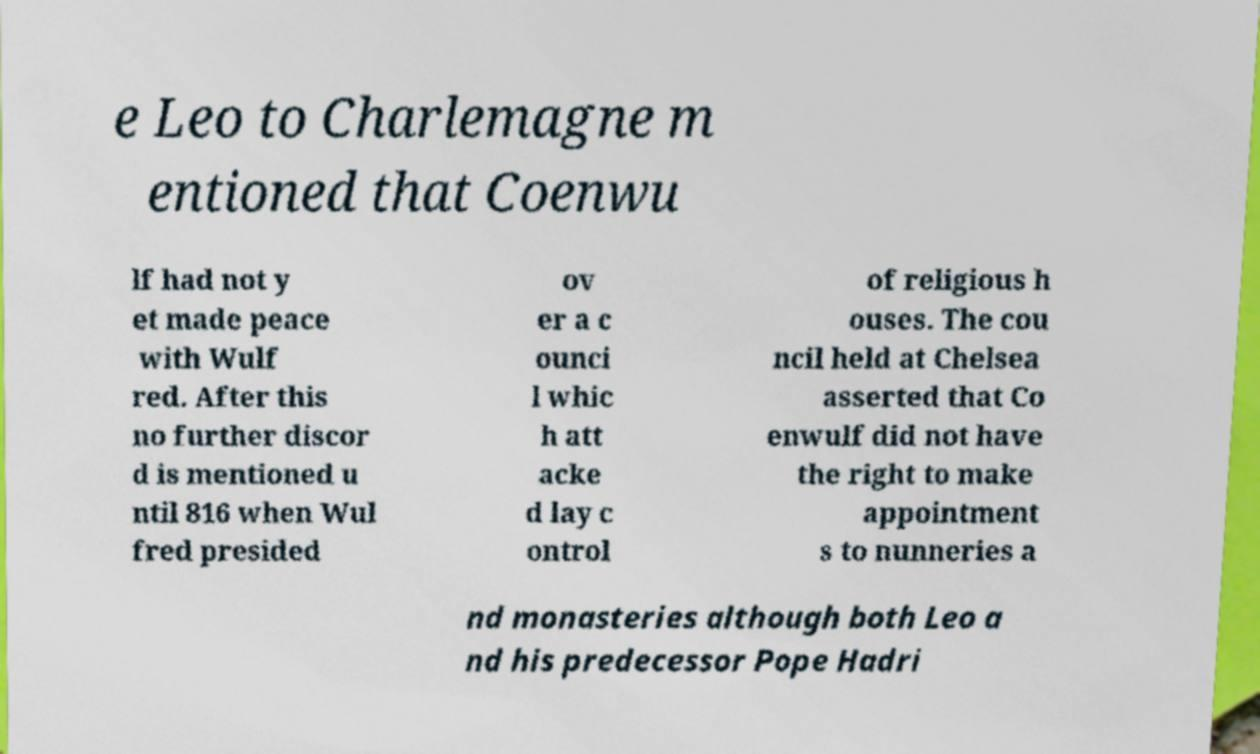Could you assist in decoding the text presented in this image and type it out clearly? e Leo to Charlemagne m entioned that Coenwu lf had not y et made peace with Wulf red. After this no further discor d is mentioned u ntil 816 when Wul fred presided ov er a c ounci l whic h att acke d lay c ontrol of religious h ouses. The cou ncil held at Chelsea asserted that Co enwulf did not have the right to make appointment s to nunneries a nd monasteries although both Leo a nd his predecessor Pope Hadri 